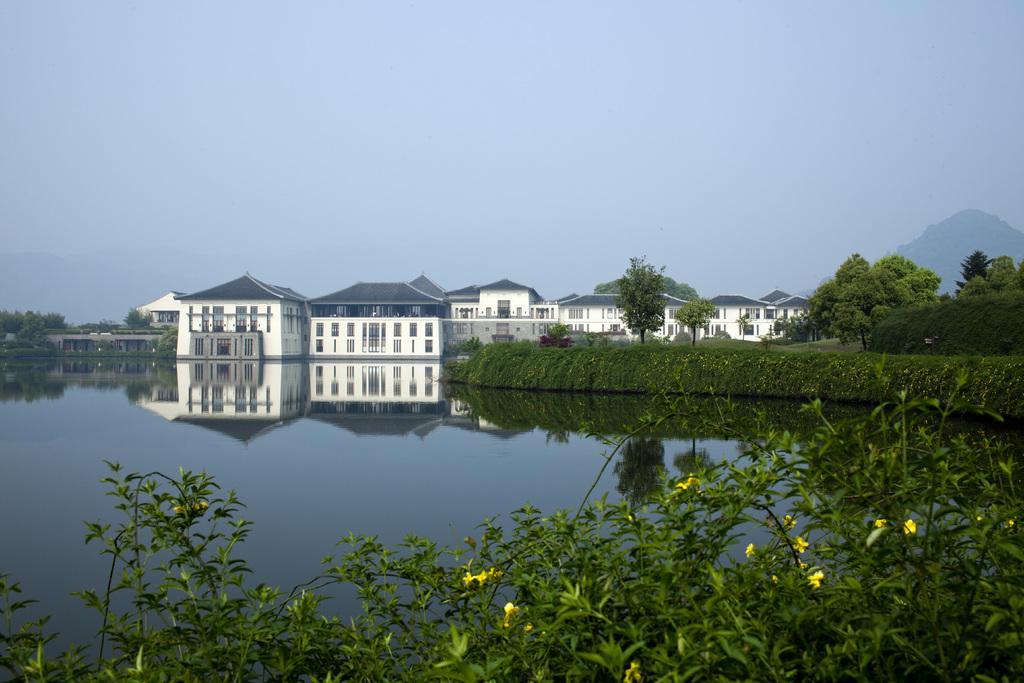Can you describe this image briefly? As we can see in the image there are plants, trees, flowers, water, buildings and sky. 